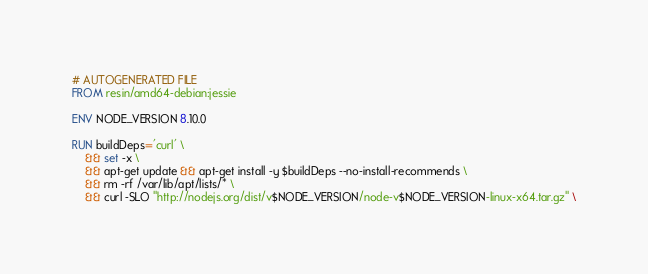Convert code to text. <code><loc_0><loc_0><loc_500><loc_500><_Dockerfile_># AUTOGENERATED FILE
FROM resin/amd64-debian:jessie

ENV NODE_VERSION 8.10.0

RUN buildDeps='curl' \
	&& set -x \
	&& apt-get update && apt-get install -y $buildDeps --no-install-recommends \
	&& rm -rf /var/lib/apt/lists/* \
	&& curl -SLO "http://nodejs.org/dist/v$NODE_VERSION/node-v$NODE_VERSION-linux-x64.tar.gz" \</code> 